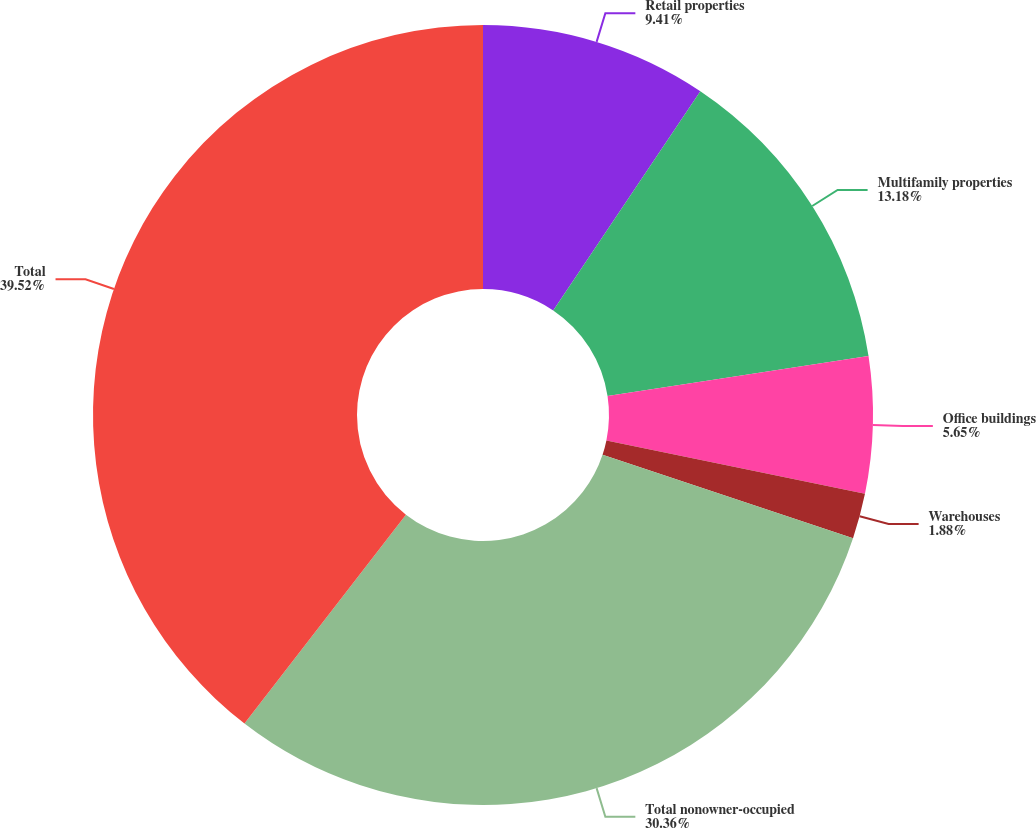Convert chart to OTSL. <chart><loc_0><loc_0><loc_500><loc_500><pie_chart><fcel>Retail properties<fcel>Multifamily properties<fcel>Office buildings<fcel>Warehouses<fcel>Total nonowner-occupied<fcel>Total<nl><fcel>9.41%<fcel>13.18%<fcel>5.65%<fcel>1.88%<fcel>30.36%<fcel>39.53%<nl></chart> 